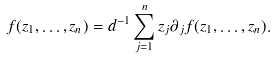<formula> <loc_0><loc_0><loc_500><loc_500>f ( z _ { 1 } , \dots , z _ { n } ) = d ^ { - 1 } \sum _ { j = 1 } ^ { n } z _ { j } \partial _ { j } f ( z _ { 1 } , \dots , z _ { n } ) .</formula> 